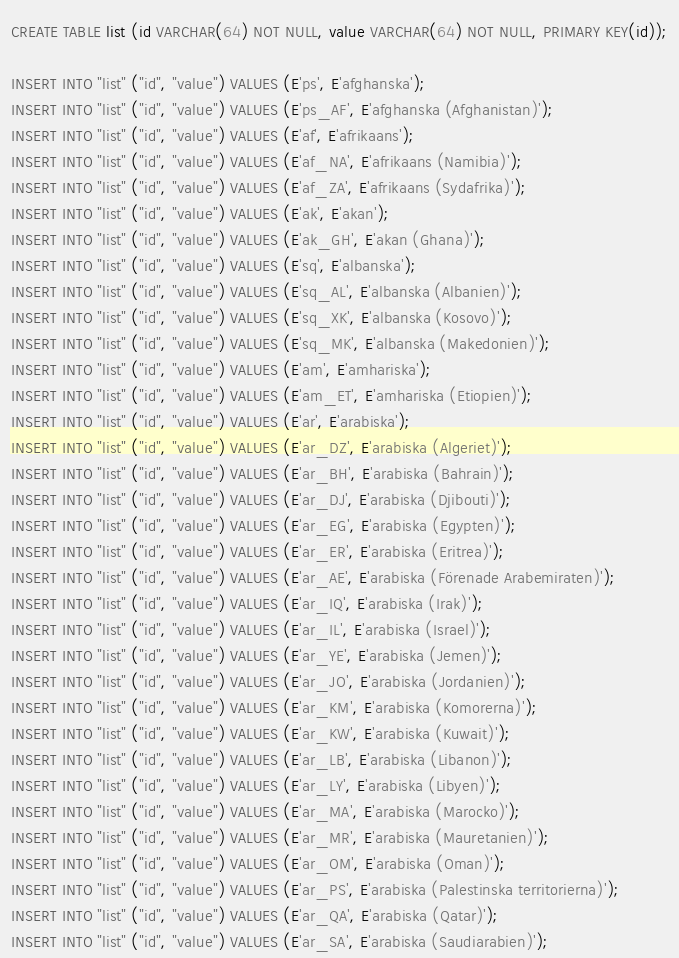Convert code to text. <code><loc_0><loc_0><loc_500><loc_500><_SQL_>CREATE TABLE list (id VARCHAR(64) NOT NULL, value VARCHAR(64) NOT NULL, PRIMARY KEY(id));

INSERT INTO "list" ("id", "value") VALUES (E'ps', E'afghanska');
INSERT INTO "list" ("id", "value") VALUES (E'ps_AF', E'afghanska (Afghanistan)');
INSERT INTO "list" ("id", "value") VALUES (E'af', E'afrikaans');
INSERT INTO "list" ("id", "value") VALUES (E'af_NA', E'afrikaans (Namibia)');
INSERT INTO "list" ("id", "value") VALUES (E'af_ZA', E'afrikaans (Sydafrika)');
INSERT INTO "list" ("id", "value") VALUES (E'ak', E'akan');
INSERT INTO "list" ("id", "value") VALUES (E'ak_GH', E'akan (Ghana)');
INSERT INTO "list" ("id", "value") VALUES (E'sq', E'albanska');
INSERT INTO "list" ("id", "value") VALUES (E'sq_AL', E'albanska (Albanien)');
INSERT INTO "list" ("id", "value") VALUES (E'sq_XK', E'albanska (Kosovo)');
INSERT INTO "list" ("id", "value") VALUES (E'sq_MK', E'albanska (Makedonien)');
INSERT INTO "list" ("id", "value") VALUES (E'am', E'amhariska');
INSERT INTO "list" ("id", "value") VALUES (E'am_ET', E'amhariska (Etiopien)');
INSERT INTO "list" ("id", "value") VALUES (E'ar', E'arabiska');
INSERT INTO "list" ("id", "value") VALUES (E'ar_DZ', E'arabiska (Algeriet)');
INSERT INTO "list" ("id", "value") VALUES (E'ar_BH', E'arabiska (Bahrain)');
INSERT INTO "list" ("id", "value") VALUES (E'ar_DJ', E'arabiska (Djibouti)');
INSERT INTO "list" ("id", "value") VALUES (E'ar_EG', E'arabiska (Egypten)');
INSERT INTO "list" ("id", "value") VALUES (E'ar_ER', E'arabiska (Eritrea)');
INSERT INTO "list" ("id", "value") VALUES (E'ar_AE', E'arabiska (Förenade Arabemiraten)');
INSERT INTO "list" ("id", "value") VALUES (E'ar_IQ', E'arabiska (Irak)');
INSERT INTO "list" ("id", "value") VALUES (E'ar_IL', E'arabiska (Israel)');
INSERT INTO "list" ("id", "value") VALUES (E'ar_YE', E'arabiska (Jemen)');
INSERT INTO "list" ("id", "value") VALUES (E'ar_JO', E'arabiska (Jordanien)');
INSERT INTO "list" ("id", "value") VALUES (E'ar_KM', E'arabiska (Komorerna)');
INSERT INTO "list" ("id", "value") VALUES (E'ar_KW', E'arabiska (Kuwait)');
INSERT INTO "list" ("id", "value") VALUES (E'ar_LB', E'arabiska (Libanon)');
INSERT INTO "list" ("id", "value") VALUES (E'ar_LY', E'arabiska (Libyen)');
INSERT INTO "list" ("id", "value") VALUES (E'ar_MA', E'arabiska (Marocko)');
INSERT INTO "list" ("id", "value") VALUES (E'ar_MR', E'arabiska (Mauretanien)');
INSERT INTO "list" ("id", "value") VALUES (E'ar_OM', E'arabiska (Oman)');
INSERT INTO "list" ("id", "value") VALUES (E'ar_PS', E'arabiska (Palestinska territorierna)');
INSERT INTO "list" ("id", "value") VALUES (E'ar_QA', E'arabiska (Qatar)');
INSERT INTO "list" ("id", "value") VALUES (E'ar_SA', E'arabiska (Saudiarabien)');</code> 